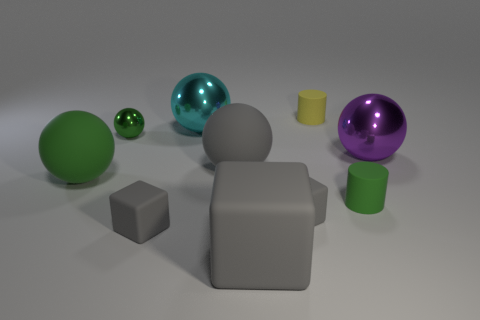What would you say is the mood or atmosphere conveyed by this image? The image conveys a serene and orderly atmosphere, with its balanced composition and soft diffuse lighting. 